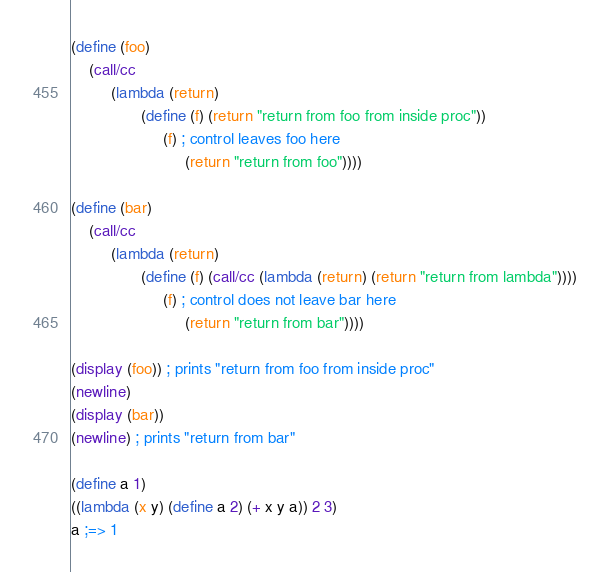Convert code to text. <code><loc_0><loc_0><loc_500><loc_500><_Scheme_>(define (foo)
    (call/cc
         (lambda (return)
                (define (f) (return "return from foo from inside proc"))
                     (f) ; control leaves foo here
                          (return "return from foo"))))

(define (bar)
    (call/cc
         (lambda (return)
                (define (f) (call/cc (lambda (return) (return "return from lambda"))))
                     (f) ; control does not leave bar here
                          (return "return from bar"))))

(display (foo)) ; prints "return from foo from inside proc"
(newline)
(display (bar))
(newline) ; prints "return from bar"

(define a 1)
((lambda (x y) (define a 2) (+ x y a)) 2 3)
a ;=> 1</code> 